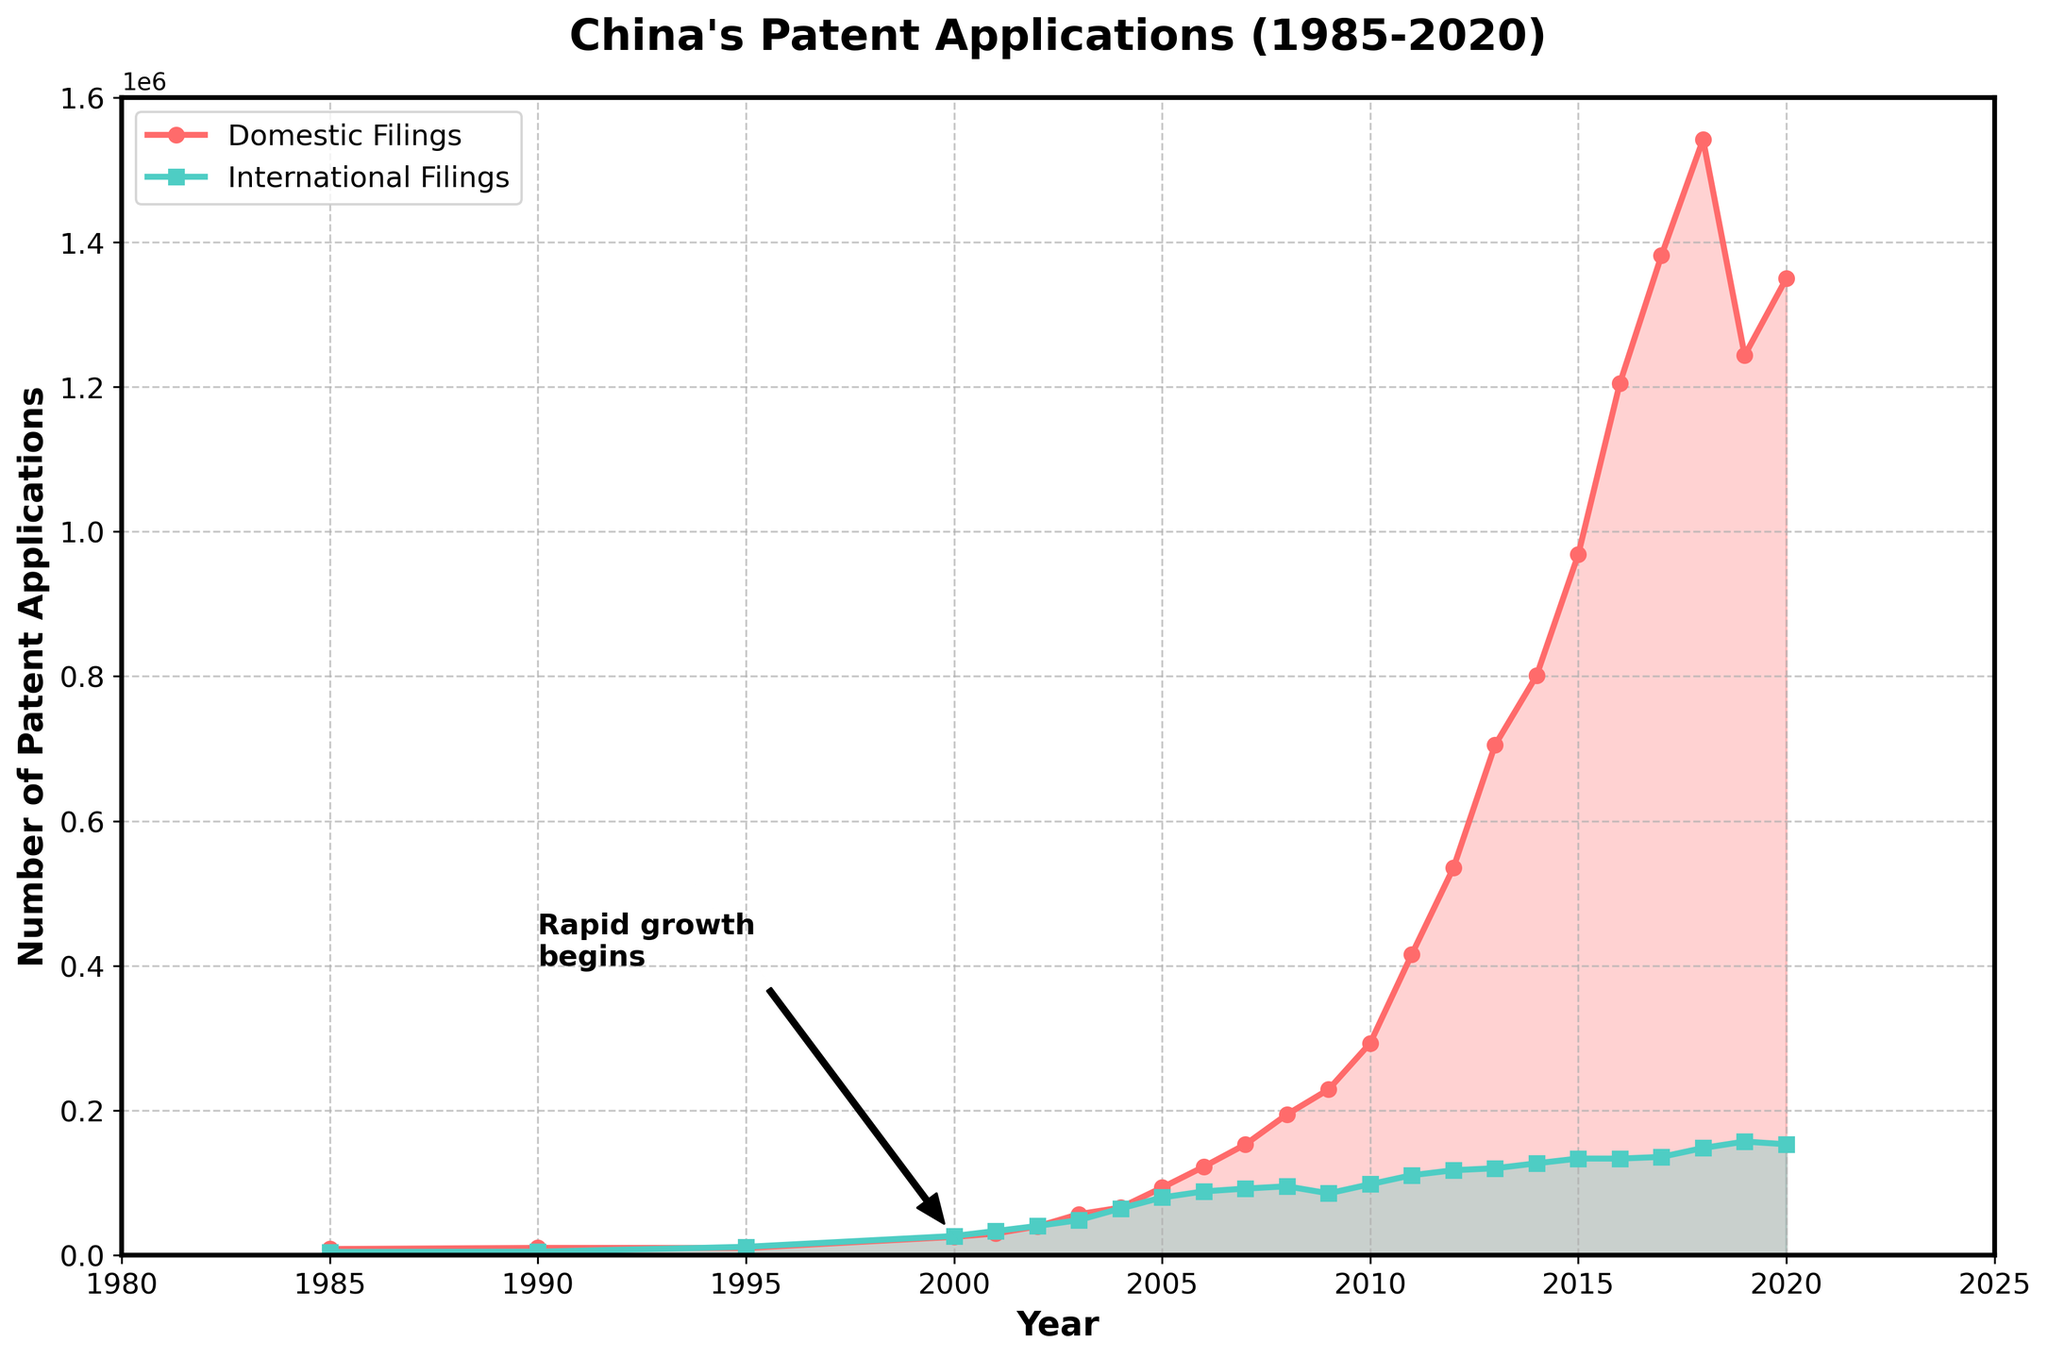What's the highest number of domestic patent filings recorded during the period? To determine this, look at the peak of the red line representing domestic filings. The highest point on the red line occurs in 2018 with approximately 1,542,002 filings.
Answer: 1,542,002 How did domestic patent filings compare to international filings in 1995? Look at the values for both lines in 1995. For domestic filings, the value is about 10,011, whereas for international filings, the value is around 11,618. Since 11,618 > 10,011, international filings were higher in 1995.
Answer: International filings were higher When did domestic patent filings begin to significantly outpace international filings? Examine the relative steepness and separation of the lines. Around 2001, the gap starts widening, with domestic filings increasing significantly faster than international filings.
Answer: Around 2001 Between which years did the domestic patent filings show the most rapid increase? Observe the steepest portion of the red line. The most rapid increase is from 2010 (293,066) to 2018 (1,542,002).
Answer: 2010 to 2018 Around which year is the ‘Rapid growth begins’ annotation pointing to, and in which direction is the arrow pointing? The annotation text "Rapid growth begins" is pointing towards the year 2000, with the arrow originating from approximately 1990 and pointing downwards to 2000.
Answer: Year 2000, pointing downwards What visual difference is there in the way domestic and international filings are presented in the plot? Domestic filings are represented with red-filled regions and circles, while international filings are represented with green-filled regions and squares.
Answer: Red for domestic, green for international How much greater were the domestic filings compared to the international filings in 2015? Subtract the number of international filings (133,612) from domestic filings (968,252) in the year 2015. 968,252 - 133,612 = 834,640
Answer: 834,640 Identify the overall trend in international filings from 1985 to 2020. Did they increase, decrease, or stay the same? Examine the green line. It shows a gradual increase over the entire period, indicating a general upward trend.
Answer: Increase In which year did both domestic and international filings first exceed 50,000 each? Find the year when both lines cross above 50,000. This first happens around 2002, where domestic filings are roughly 39,806 and international filings are about 40,426.
Answer: Around 2002 Relative to the other years, what is notable about the number of international filings in 2009? The green line shows a dip in international filings in 2009 compared to the preceding and following years. It's one of the few dips in an otherwise upward trend.
Answer: A dip in filings 